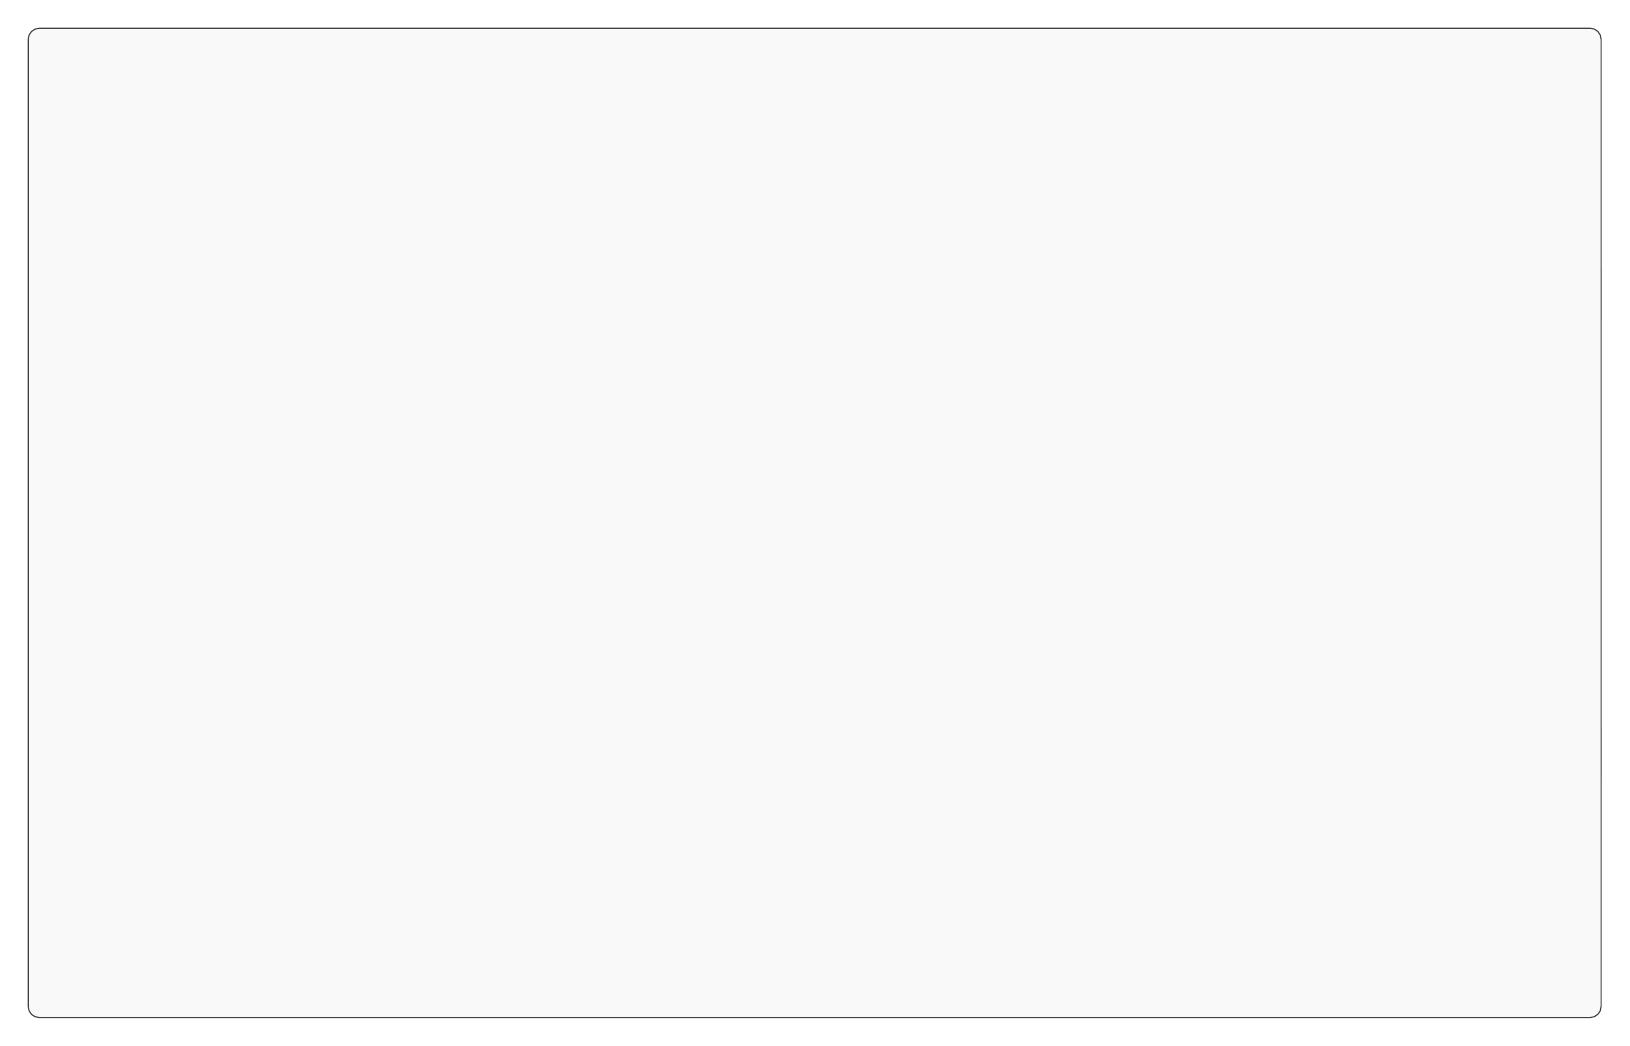What is the first step in the workflow? The first node in the flow chart represents the initial action to be taken, which is "Import Raw Footage." This is the starting point of the editing workflow, so it can be identified as the first step.
Answer: Import Raw Footage How many nodes are in the diagram? To determine the number of nodes, we can count each distinct process listed in the diagram. There are a total of nine processes represented in the workflow.
Answer: Nine What comes after "Construct Rough Cut"? By following the arrows in the flow chart, I can see that the process that follows "Construct Rough Cut" is "Incorporate Sound Design," as depicted by the directed connection leading from one to the other.
Answer: Incorporate Sound Design Which processes involve sound? In the diagram, the process "Incorporate Sound Design" explicitly mentions adding sound elements. This is the only process related to sound, so I can conclude that it is the singular focus on sound within the entire workflow.
Answer: Incorporate Sound Design What is the final step in the editing workflow? The last node, which indicates the conclusion of the workflow, is "Final Export." The positioning of this node in the flow chart indicates that it is the end point of the entire editing process.
Answer: Final Export What is the relationship between "Review Dailies" and "Select Best Takes"? The relationship is a directional progression, where "Review Dailies" leads to "Select Best Takes." This indicates that after reviewing dailies, the next action is to select the best takes from that footage.
Answer: Leads to How many edges are in the diagram? The edges represent the connections or flows between the nodes. By counting the directed lines that connect the nodes, there are a total of eight edges present in the flow chart.
Answer: Eight Describe the workflow from "Color Grading" to "Final Export". Starting from "Color Grading," the flow progresses as follows: from "Color Grading" to "Fine-Tune Edit," then to "Review and Feedback," and finally ending at "Final Export." This sequence outlines the necessary steps leading to the final output.
Answer: Color Grading to Fine-Tune Edit to Review and Feedback to Final Export 